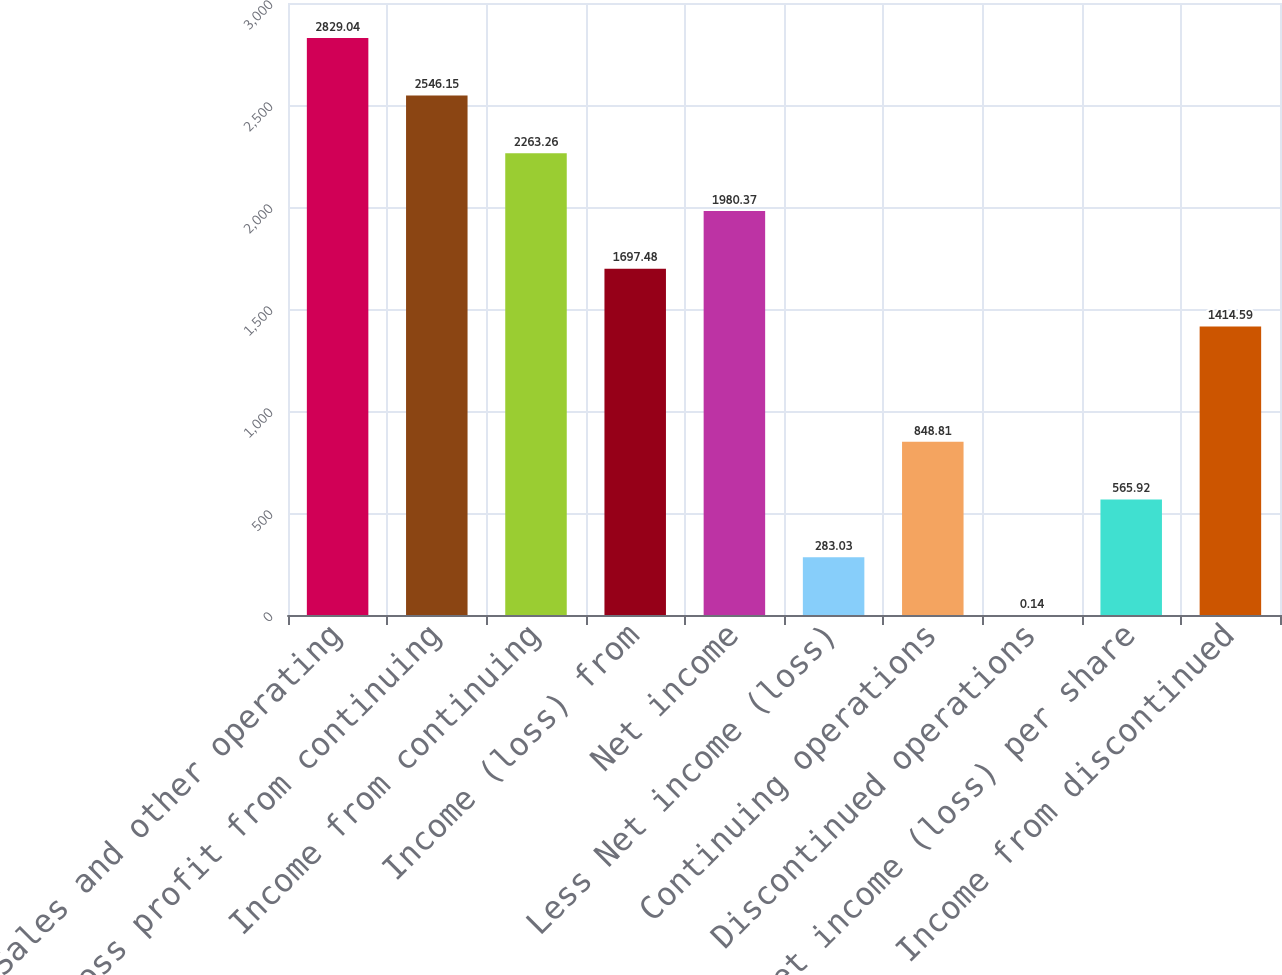Convert chart. <chart><loc_0><loc_0><loc_500><loc_500><bar_chart><fcel>Sales and other operating<fcel>Gross profit from continuing<fcel>Income from continuing<fcel>Income (loss) from<fcel>Net income<fcel>Less Net income (loss)<fcel>Continuing operations<fcel>Discontinued operations<fcel>Net income (loss) per share<fcel>Income from discontinued<nl><fcel>2829.04<fcel>2546.15<fcel>2263.26<fcel>1697.48<fcel>1980.37<fcel>283.03<fcel>848.81<fcel>0.14<fcel>565.92<fcel>1414.59<nl></chart> 